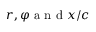<formula> <loc_0><loc_0><loc_500><loc_500>r , \varphi a n d x / c</formula> 